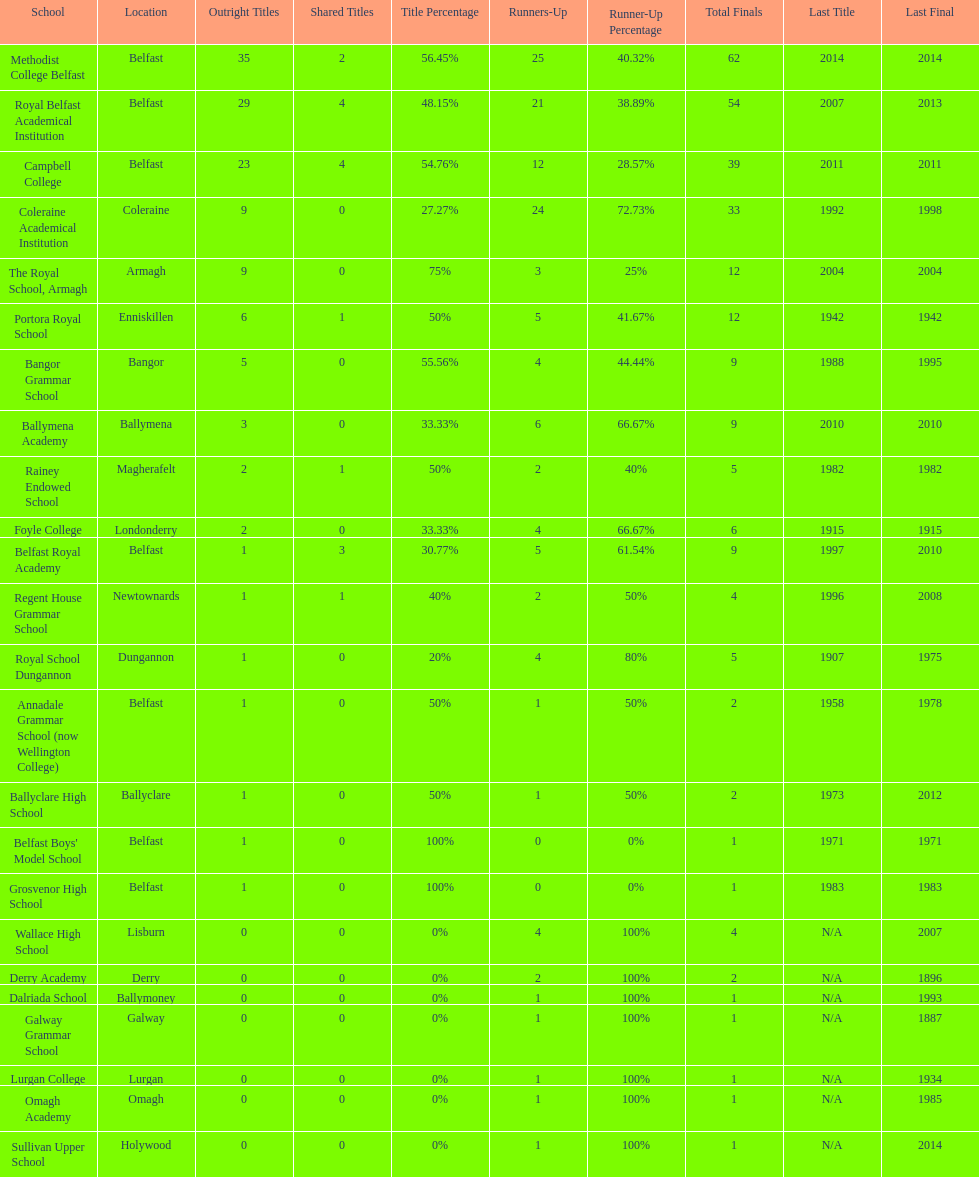How many schools have at least 5 outright titles? 7. 